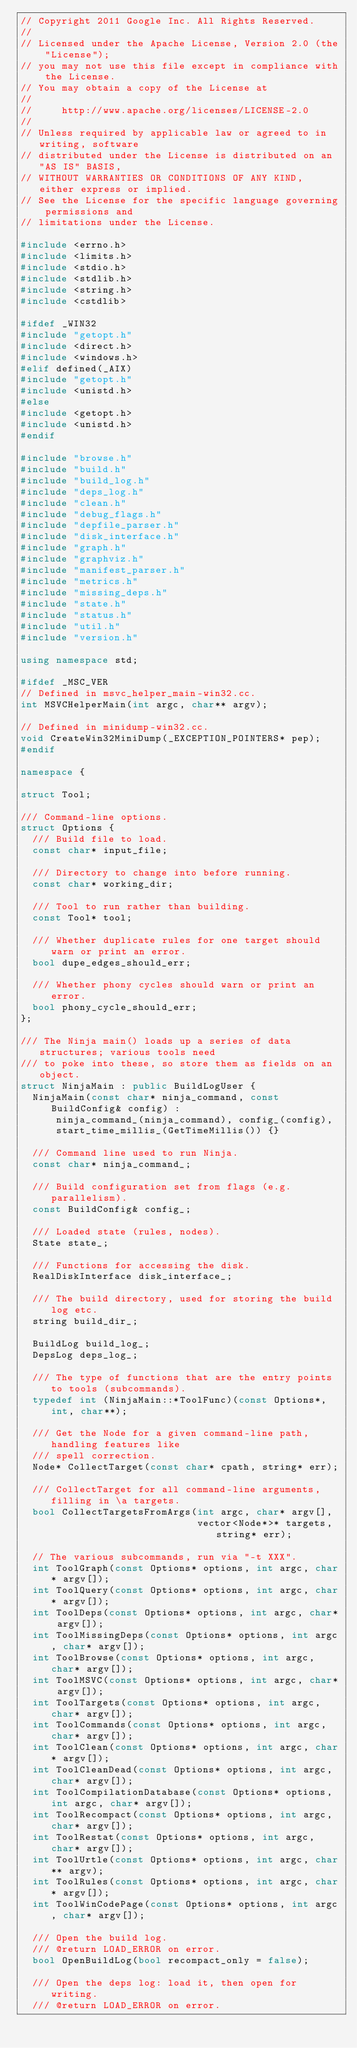Convert code to text. <code><loc_0><loc_0><loc_500><loc_500><_C++_>// Copyright 2011 Google Inc. All Rights Reserved.
//
// Licensed under the Apache License, Version 2.0 (the "License");
// you may not use this file except in compliance with the License.
// You may obtain a copy of the License at
//
//     http://www.apache.org/licenses/LICENSE-2.0
//
// Unless required by applicable law or agreed to in writing, software
// distributed under the License is distributed on an "AS IS" BASIS,
// WITHOUT WARRANTIES OR CONDITIONS OF ANY KIND, either express or implied.
// See the License for the specific language governing permissions and
// limitations under the License.

#include <errno.h>
#include <limits.h>
#include <stdio.h>
#include <stdlib.h>
#include <string.h>
#include <cstdlib>

#ifdef _WIN32
#include "getopt.h"
#include <direct.h>
#include <windows.h>
#elif defined(_AIX)
#include "getopt.h"
#include <unistd.h>
#else
#include <getopt.h>
#include <unistd.h>
#endif

#include "browse.h"
#include "build.h"
#include "build_log.h"
#include "deps_log.h"
#include "clean.h"
#include "debug_flags.h"
#include "depfile_parser.h"
#include "disk_interface.h"
#include "graph.h"
#include "graphviz.h"
#include "manifest_parser.h"
#include "metrics.h"
#include "missing_deps.h"
#include "state.h"
#include "status.h"
#include "util.h"
#include "version.h"

using namespace std;

#ifdef _MSC_VER
// Defined in msvc_helper_main-win32.cc.
int MSVCHelperMain(int argc, char** argv);

// Defined in minidump-win32.cc.
void CreateWin32MiniDump(_EXCEPTION_POINTERS* pep);
#endif

namespace {

struct Tool;

/// Command-line options.
struct Options {
  /// Build file to load.
  const char* input_file;

  /// Directory to change into before running.
  const char* working_dir;

  /// Tool to run rather than building.
  const Tool* tool;

  /// Whether duplicate rules for one target should warn or print an error.
  bool dupe_edges_should_err;

  /// Whether phony cycles should warn or print an error.
  bool phony_cycle_should_err;
};

/// The Ninja main() loads up a series of data structures; various tools need
/// to poke into these, so store them as fields on an object.
struct NinjaMain : public BuildLogUser {
  NinjaMain(const char* ninja_command, const BuildConfig& config) :
      ninja_command_(ninja_command), config_(config),
      start_time_millis_(GetTimeMillis()) {}

  /// Command line used to run Ninja.
  const char* ninja_command_;

  /// Build configuration set from flags (e.g. parallelism).
  const BuildConfig& config_;

  /// Loaded state (rules, nodes).
  State state_;

  /// Functions for accessing the disk.
  RealDiskInterface disk_interface_;

  /// The build directory, used for storing the build log etc.
  string build_dir_;

  BuildLog build_log_;
  DepsLog deps_log_;

  /// The type of functions that are the entry points to tools (subcommands).
  typedef int (NinjaMain::*ToolFunc)(const Options*, int, char**);

  /// Get the Node for a given command-line path, handling features like
  /// spell correction.
  Node* CollectTarget(const char* cpath, string* err);

  /// CollectTarget for all command-line arguments, filling in \a targets.
  bool CollectTargetsFromArgs(int argc, char* argv[],
                              vector<Node*>* targets, string* err);

  // The various subcommands, run via "-t XXX".
  int ToolGraph(const Options* options, int argc, char* argv[]);
  int ToolQuery(const Options* options, int argc, char* argv[]);
  int ToolDeps(const Options* options, int argc, char* argv[]);
  int ToolMissingDeps(const Options* options, int argc, char* argv[]);
  int ToolBrowse(const Options* options, int argc, char* argv[]);
  int ToolMSVC(const Options* options, int argc, char* argv[]);
  int ToolTargets(const Options* options, int argc, char* argv[]);
  int ToolCommands(const Options* options, int argc, char* argv[]);
  int ToolClean(const Options* options, int argc, char* argv[]);
  int ToolCleanDead(const Options* options, int argc, char* argv[]);
  int ToolCompilationDatabase(const Options* options, int argc, char* argv[]);
  int ToolRecompact(const Options* options, int argc, char* argv[]);
  int ToolRestat(const Options* options, int argc, char* argv[]);
  int ToolUrtle(const Options* options, int argc, char** argv);
  int ToolRules(const Options* options, int argc, char* argv[]);
  int ToolWinCodePage(const Options* options, int argc, char* argv[]);

  /// Open the build log.
  /// @return LOAD_ERROR on error.
  bool OpenBuildLog(bool recompact_only = false);

  /// Open the deps log: load it, then open for writing.
  /// @return LOAD_ERROR on error.</code> 